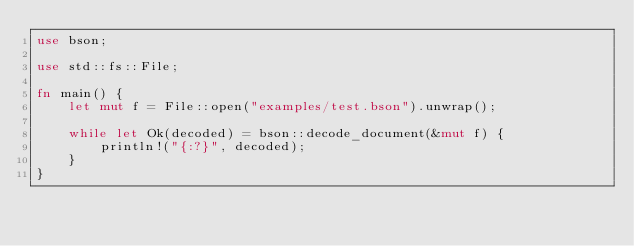Convert code to text. <code><loc_0><loc_0><loc_500><loc_500><_Rust_>use bson;

use std::fs::File;

fn main() {
    let mut f = File::open("examples/test.bson").unwrap();

    while let Ok(decoded) = bson::decode_document(&mut f) {
        println!("{:?}", decoded);
    }
}
</code> 